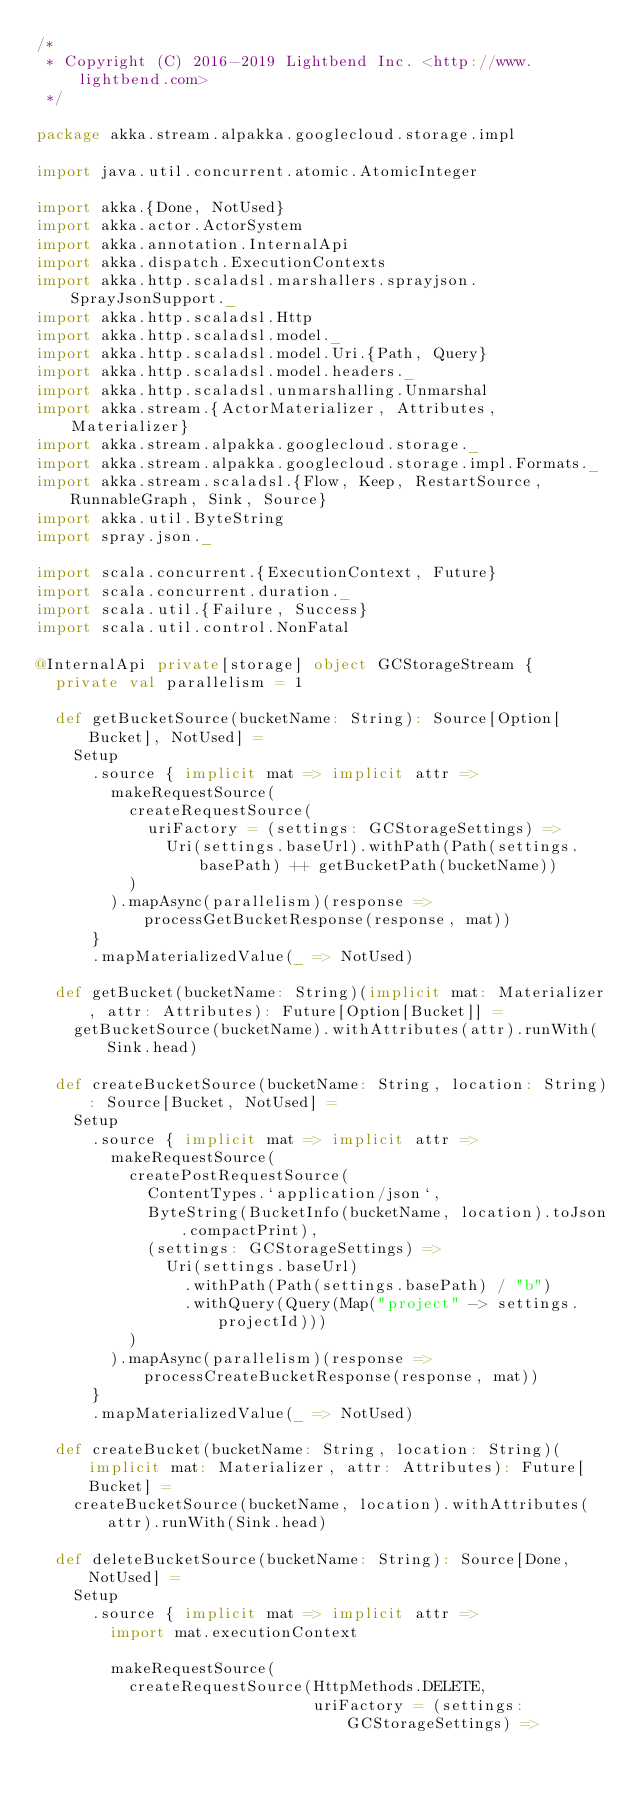<code> <loc_0><loc_0><loc_500><loc_500><_Scala_>/*
 * Copyright (C) 2016-2019 Lightbend Inc. <http://www.lightbend.com>
 */

package akka.stream.alpakka.googlecloud.storage.impl

import java.util.concurrent.atomic.AtomicInteger

import akka.{Done, NotUsed}
import akka.actor.ActorSystem
import akka.annotation.InternalApi
import akka.dispatch.ExecutionContexts
import akka.http.scaladsl.marshallers.sprayjson.SprayJsonSupport._
import akka.http.scaladsl.Http
import akka.http.scaladsl.model._
import akka.http.scaladsl.model.Uri.{Path, Query}
import akka.http.scaladsl.model.headers._
import akka.http.scaladsl.unmarshalling.Unmarshal
import akka.stream.{ActorMaterializer, Attributes, Materializer}
import akka.stream.alpakka.googlecloud.storage._
import akka.stream.alpakka.googlecloud.storage.impl.Formats._
import akka.stream.scaladsl.{Flow, Keep, RestartSource, RunnableGraph, Sink, Source}
import akka.util.ByteString
import spray.json._

import scala.concurrent.{ExecutionContext, Future}
import scala.concurrent.duration._
import scala.util.{Failure, Success}
import scala.util.control.NonFatal

@InternalApi private[storage] object GCStorageStream {
  private val parallelism = 1

  def getBucketSource(bucketName: String): Source[Option[Bucket], NotUsed] =
    Setup
      .source { implicit mat => implicit attr =>
        makeRequestSource(
          createRequestSource(
            uriFactory = (settings: GCStorageSettings) =>
              Uri(settings.baseUrl).withPath(Path(settings.basePath) ++ getBucketPath(bucketName))
          )
        ).mapAsync(parallelism)(response => processGetBucketResponse(response, mat))
      }
      .mapMaterializedValue(_ => NotUsed)

  def getBucket(bucketName: String)(implicit mat: Materializer, attr: Attributes): Future[Option[Bucket]] =
    getBucketSource(bucketName).withAttributes(attr).runWith(Sink.head)

  def createBucketSource(bucketName: String, location: String): Source[Bucket, NotUsed] =
    Setup
      .source { implicit mat => implicit attr =>
        makeRequestSource(
          createPostRequestSource(
            ContentTypes.`application/json`,
            ByteString(BucketInfo(bucketName, location).toJson.compactPrint),
            (settings: GCStorageSettings) =>
              Uri(settings.baseUrl)
                .withPath(Path(settings.basePath) / "b")
                .withQuery(Query(Map("project" -> settings.projectId)))
          )
        ).mapAsync(parallelism)(response => processCreateBucketResponse(response, mat))
      }
      .mapMaterializedValue(_ => NotUsed)

  def createBucket(bucketName: String, location: String)(implicit mat: Materializer, attr: Attributes): Future[Bucket] =
    createBucketSource(bucketName, location).withAttributes(attr).runWith(Sink.head)

  def deleteBucketSource(bucketName: String): Source[Done, NotUsed] =
    Setup
      .source { implicit mat => implicit attr =>
        import mat.executionContext

        makeRequestSource(
          createRequestSource(HttpMethods.DELETE,
                              uriFactory = (settings: GCStorageSettings) =></code> 